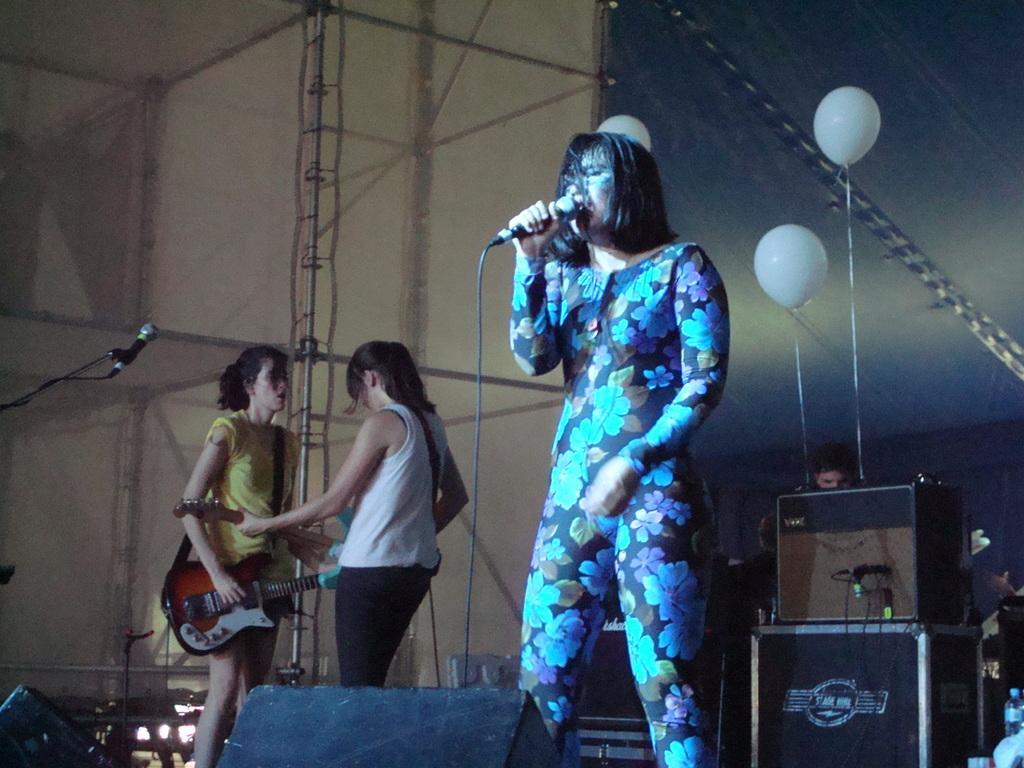In one or two sentences, can you explain what this image depicts? This woman wore floral dress and singing in-front of mic. Far this two womens are facing each other and playing guitars. At background there are balloons and devices. This is mic with holder. 